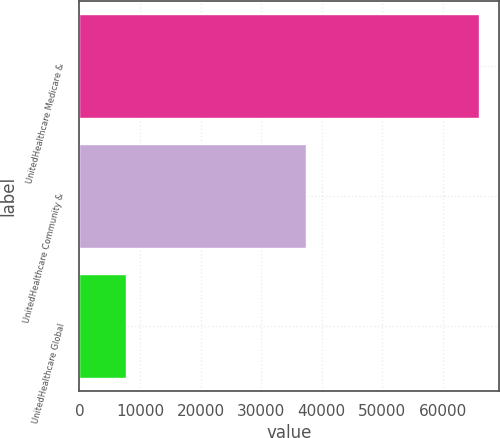Convert chart. <chart><loc_0><loc_0><loc_500><loc_500><bar_chart><fcel>UnitedHealthcare Medicare &<fcel>UnitedHealthcare Community &<fcel>UnitedHealthcare Global<nl><fcel>65995<fcel>37443<fcel>7753<nl></chart> 